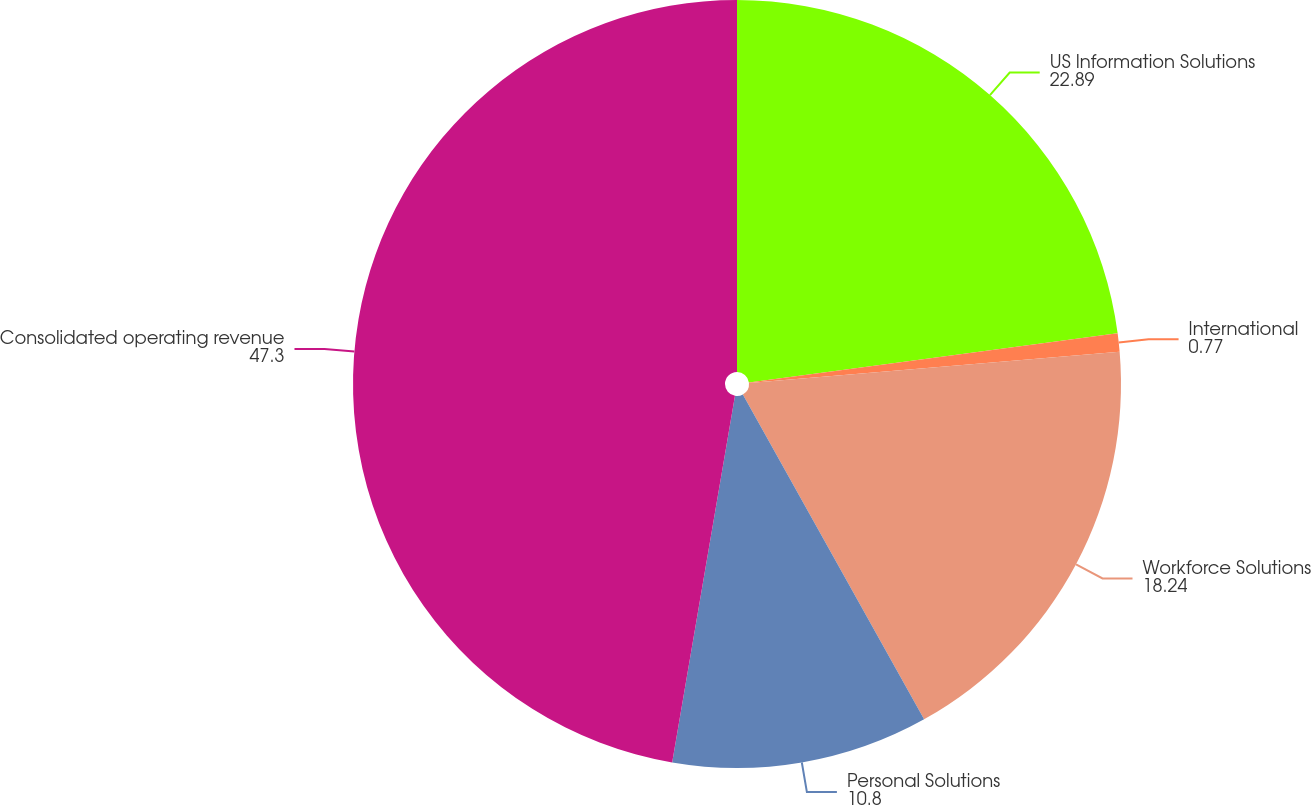Convert chart. <chart><loc_0><loc_0><loc_500><loc_500><pie_chart><fcel>US Information Solutions<fcel>International<fcel>Workforce Solutions<fcel>Personal Solutions<fcel>Consolidated operating revenue<nl><fcel>22.89%<fcel>0.77%<fcel>18.24%<fcel>10.8%<fcel>47.3%<nl></chart> 